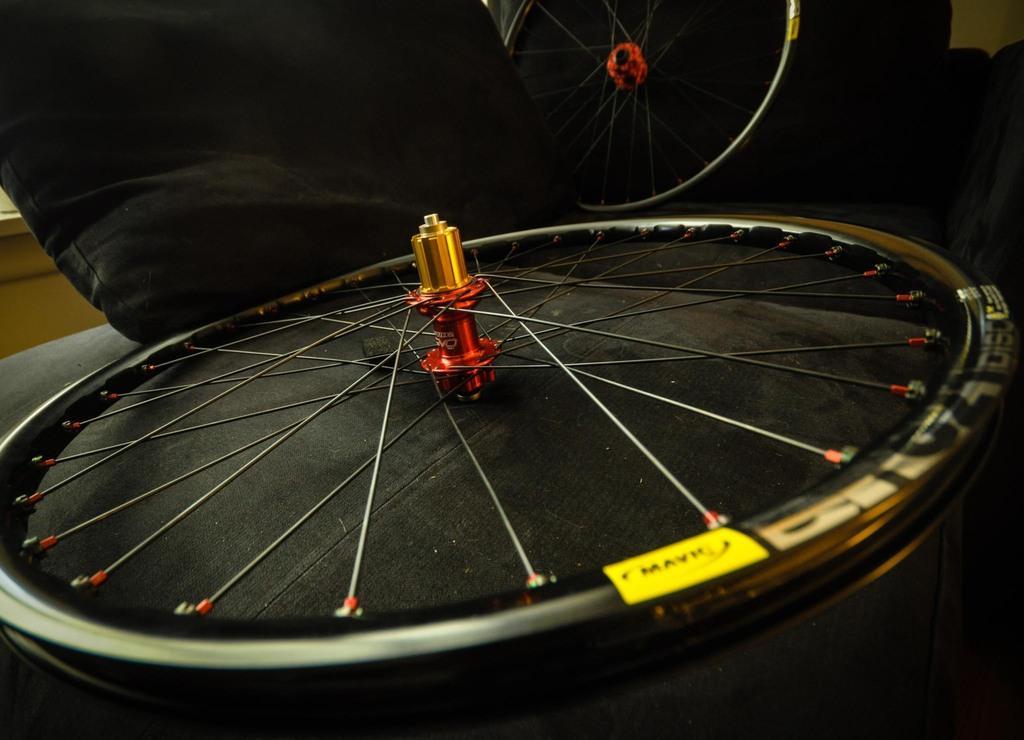Can you describe this image briefly? Here I can see a wheel on a wooden surface. In the background there is another wheel. At the top there is a black color cloth. In the background there is a table. 